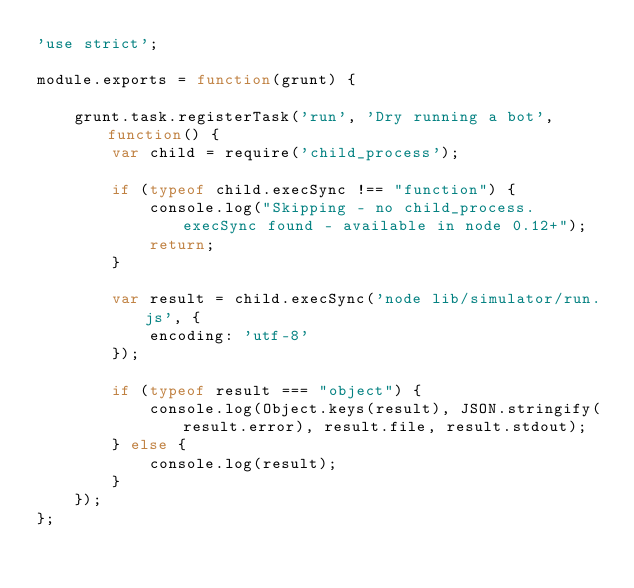<code> <loc_0><loc_0><loc_500><loc_500><_JavaScript_>'use strict';

module.exports = function(grunt) {

    grunt.task.registerTask('run', 'Dry running a bot', function() {
        var child = require('child_process');

        if (typeof child.execSync !== "function") {
            console.log("Skipping - no child_process.execSync found - available in node 0.12+");
            return;
        }

        var result = child.execSync('node lib/simulator/run.js', {
            encoding: 'utf-8'
        });

        if (typeof result === "object") {
            console.log(Object.keys(result), JSON.stringify(result.error), result.file, result.stdout);
        } else {
            console.log(result);
        }
    });
};</code> 